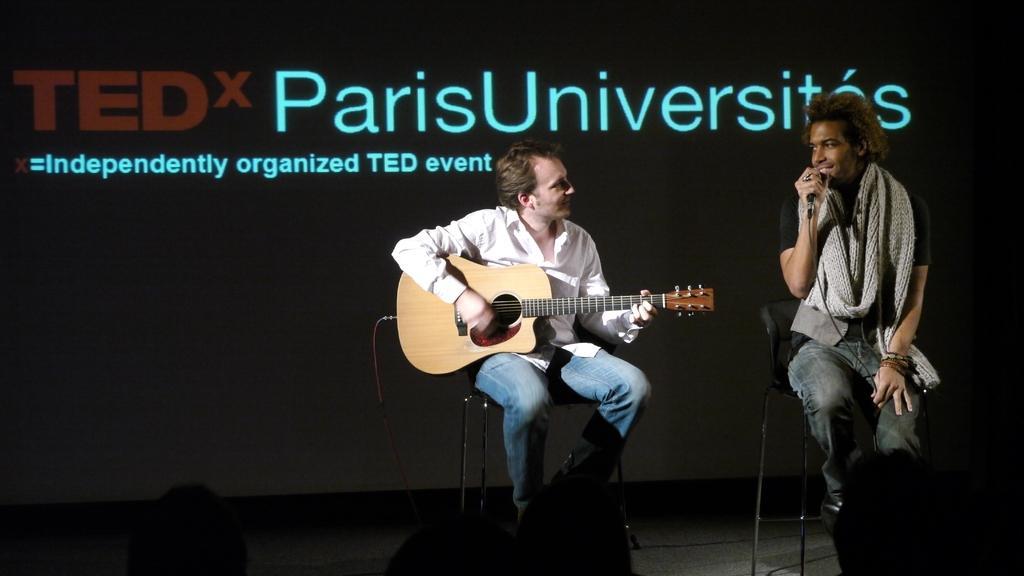Could you give a brief overview of what you see in this image? The two persons are standing. They are smiling. On the right side of the person is wearing a scarf and holding a mic. On the left side of the person is playing a guitar. We can see in the background banner. 